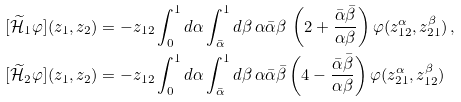Convert formula to latex. <formula><loc_0><loc_0><loc_500><loc_500>[ \widetilde { \mathcal { H } } _ { 1 } \varphi ] ( z _ { 1 } , z _ { 2 } ) & = - z _ { 1 2 } \int _ { 0 } ^ { 1 } d \alpha \int _ { \bar { \alpha } } ^ { 1 } d \beta \, \alpha \bar { \alpha } \beta \, \left ( 2 + \frac { \bar { \alpha } \bar { \beta } } { \alpha \beta } \right ) \varphi ( z _ { 1 2 } ^ { \alpha } , z _ { 2 1 } ^ { \beta } ) \, , \\ [ \widetilde { \mathcal { H } } _ { 2 } \varphi ] ( z _ { 1 } , z _ { 2 } ) & = - z _ { 1 2 } \int _ { 0 } ^ { 1 } d \alpha \int _ { \bar { \alpha } } ^ { 1 } d \beta \, \alpha \bar { \alpha } \bar { \beta } \left ( 4 - \frac { \bar { \alpha } \bar { \beta } } { \alpha \beta } \right ) \varphi ( z _ { 2 1 } ^ { \alpha } , z _ { 1 2 } ^ { \beta } ) \,</formula> 